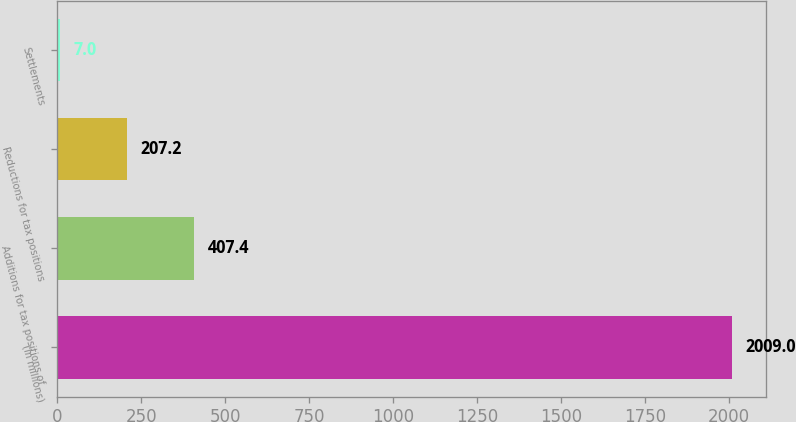<chart> <loc_0><loc_0><loc_500><loc_500><bar_chart><fcel>(In millions)<fcel>Additions for tax positions of<fcel>Reductions for tax positions<fcel>Settlements<nl><fcel>2009<fcel>407.4<fcel>207.2<fcel>7<nl></chart> 